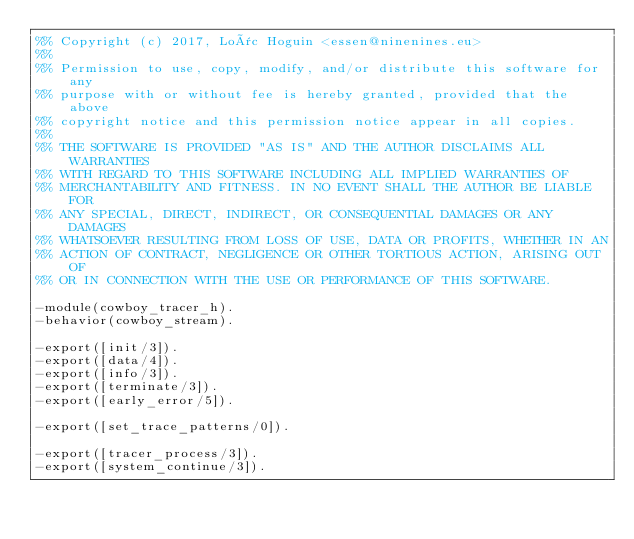<code> <loc_0><loc_0><loc_500><loc_500><_Erlang_>%% Copyright (c) 2017, Loïc Hoguin <essen@ninenines.eu>
%%
%% Permission to use, copy, modify, and/or distribute this software for any
%% purpose with or without fee is hereby granted, provided that the above
%% copyright notice and this permission notice appear in all copies.
%%
%% THE SOFTWARE IS PROVIDED "AS IS" AND THE AUTHOR DISCLAIMS ALL WARRANTIES
%% WITH REGARD TO THIS SOFTWARE INCLUDING ALL IMPLIED WARRANTIES OF
%% MERCHANTABILITY AND FITNESS. IN NO EVENT SHALL THE AUTHOR BE LIABLE FOR
%% ANY SPECIAL, DIRECT, INDIRECT, OR CONSEQUENTIAL DAMAGES OR ANY DAMAGES
%% WHATSOEVER RESULTING FROM LOSS OF USE, DATA OR PROFITS, WHETHER IN AN
%% ACTION OF CONTRACT, NEGLIGENCE OR OTHER TORTIOUS ACTION, ARISING OUT OF
%% OR IN CONNECTION WITH THE USE OR PERFORMANCE OF THIS SOFTWARE.

-module(cowboy_tracer_h).
-behavior(cowboy_stream).

-export([init/3]).
-export([data/4]).
-export([info/3]).
-export([terminate/3]).
-export([early_error/5]).

-export([set_trace_patterns/0]).

-export([tracer_process/3]).
-export([system_continue/3]).</code> 